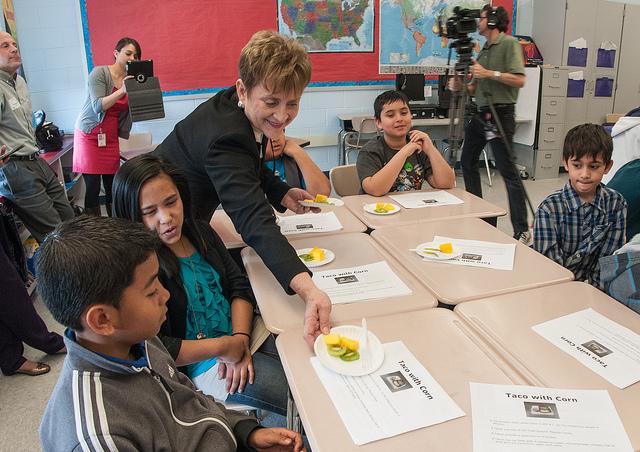What kind of computer is featured in the picture?
Quick response, please. Desktop. Are those placemats in front of the students?
Concise answer only. Yes. What is she serving the students?
Give a very brief answer. Fruit. Does the woman show the computer to the kids?
Write a very short answer. No. Are the utensils plastic?
Give a very brief answer. Yes. 